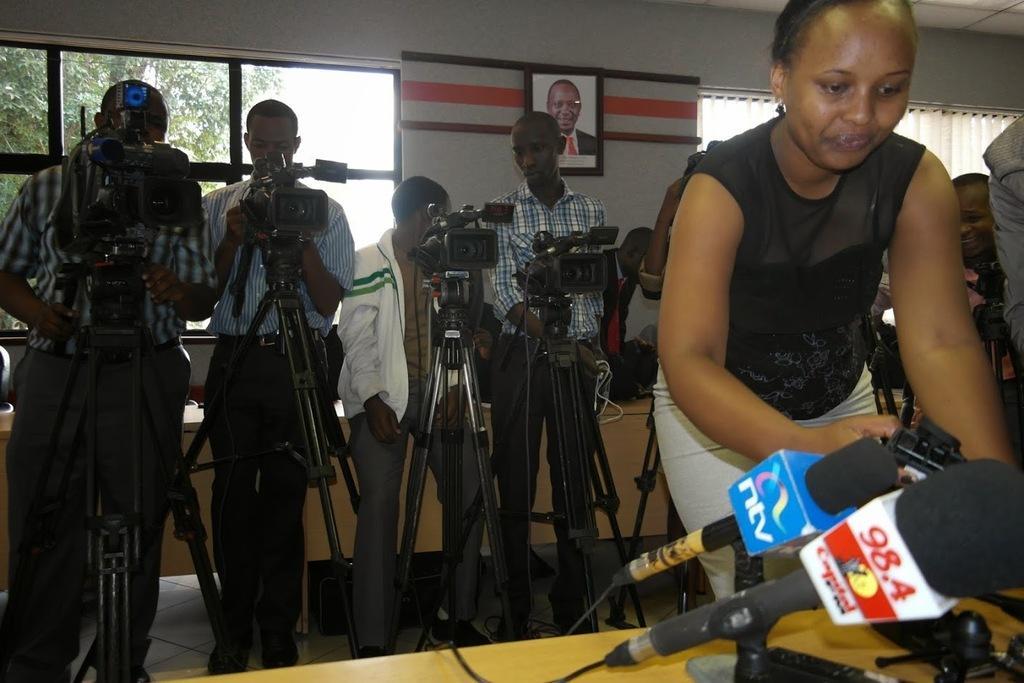Describe this image in one or two sentences. In-front of the image we can see table, mics and a woman. In the background there are people, camera, stands, windows, window blind, wall and things. Picture is on the wall. Through the window we can see tree. 